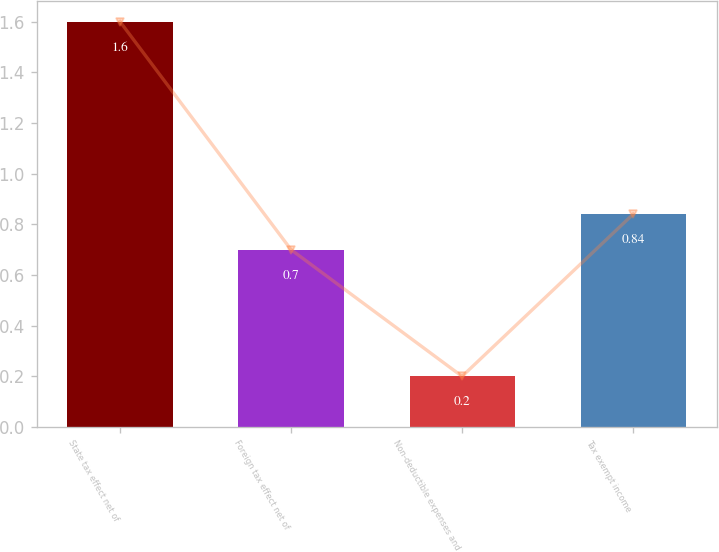Convert chart. <chart><loc_0><loc_0><loc_500><loc_500><bar_chart><fcel>State tax effect net of<fcel>Foreign tax effect net of<fcel>Non-deductible expenses and<fcel>Tax exempt income<nl><fcel>1.6<fcel>0.7<fcel>0.2<fcel>0.84<nl></chart> 